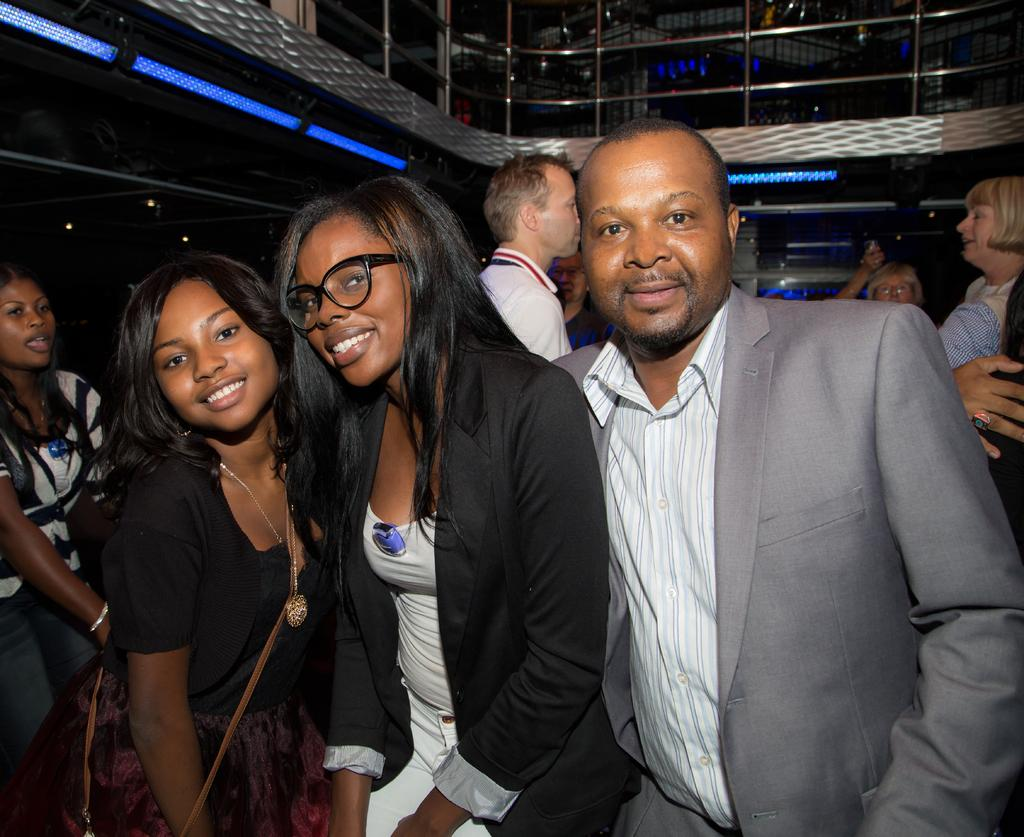What is happening in the image? There are people standing in the image. Can you describe the expressions of the people in the front? Three persons in the front are smiling. What can be seen in the background of the image? There is railing visible in the background of the image. What type of milk can be seen in the hands of the people in the image? There is no milk present in the image; the people are simply standing and smiling. 